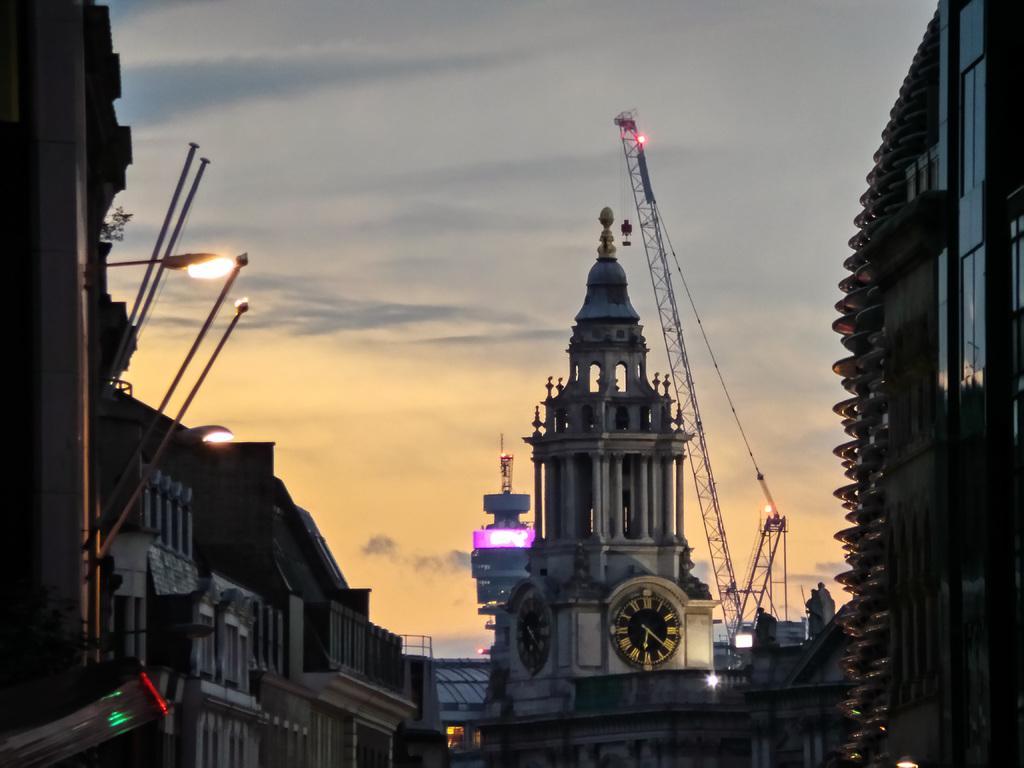Can you describe this image briefly? In this image I can see few buildings, windows, light poles, poles, vehicles and cranes. The sky is in orange, grey and white color. 